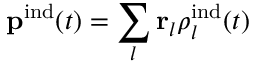<formula> <loc_0><loc_0><loc_500><loc_500>{ p } ^ { i n d } ( t ) = \sum _ { l } { r } _ { l } \rho _ { l } ^ { i n d } ( t )</formula> 